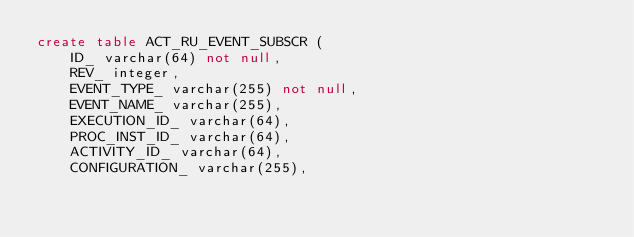Convert code to text. <code><loc_0><loc_0><loc_500><loc_500><_SQL_>create table ACT_RU_EVENT_SUBSCR (
    ID_ varchar(64) not null,
    REV_ integer,
    EVENT_TYPE_ varchar(255) not null,
    EVENT_NAME_ varchar(255),
    EXECUTION_ID_ varchar(64),
    PROC_INST_ID_ varchar(64),
    ACTIVITY_ID_ varchar(64),
    CONFIGURATION_ varchar(255),</code> 